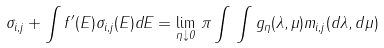Convert formula to latex. <formula><loc_0><loc_0><loc_500><loc_500>\sigma _ { i , j } + \int f ^ { \prime } ( E ) \sigma _ { i , j } ( E ) d E = \lim _ { \eta \downarrow 0 } \, \pi \int \, \int g _ { \eta } ( \lambda , \mu ) m _ { i , j } ( d \lambda , d \mu )</formula> 